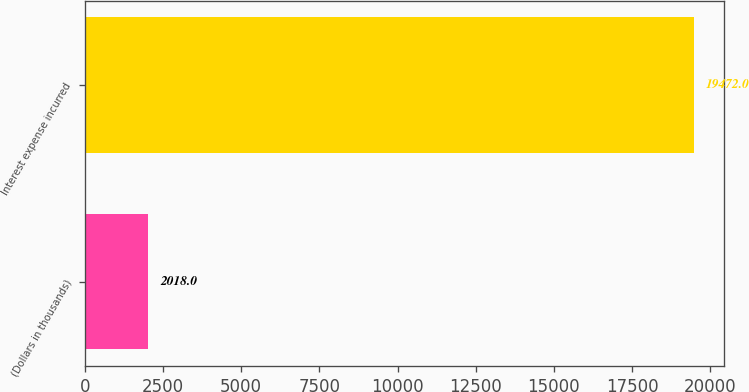Convert chart to OTSL. <chart><loc_0><loc_0><loc_500><loc_500><bar_chart><fcel>(Dollars in thousands)<fcel>Interest expense incurred<nl><fcel>2018<fcel>19472<nl></chart> 